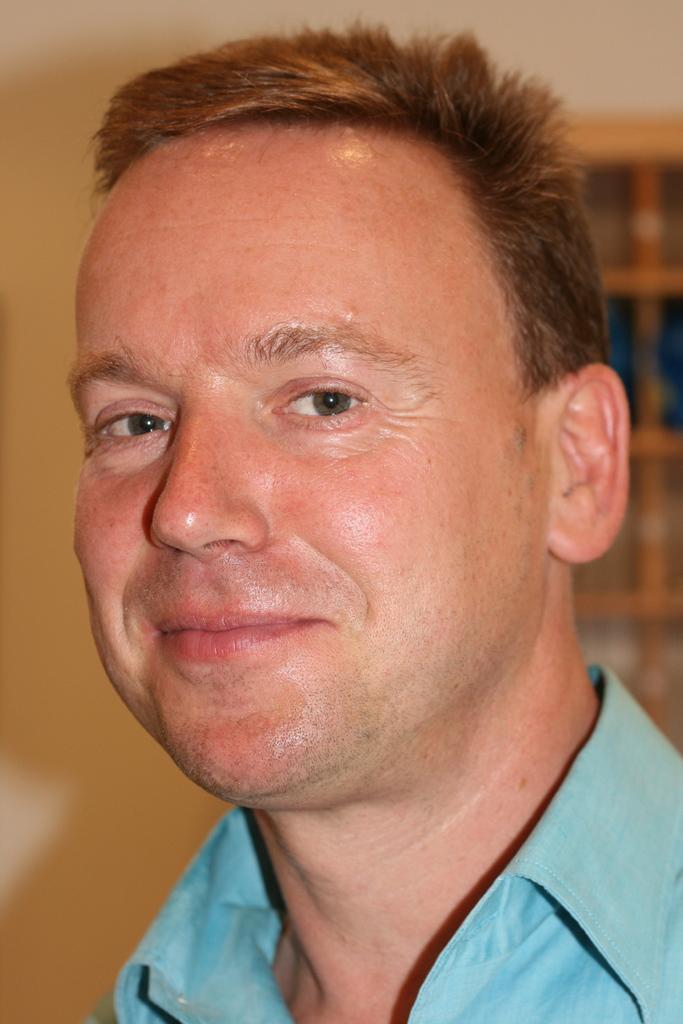In one or two sentences, can you explain what this image depicts? This image consists of a man wearing blue shirt. In the background, there is a wall along with window. 